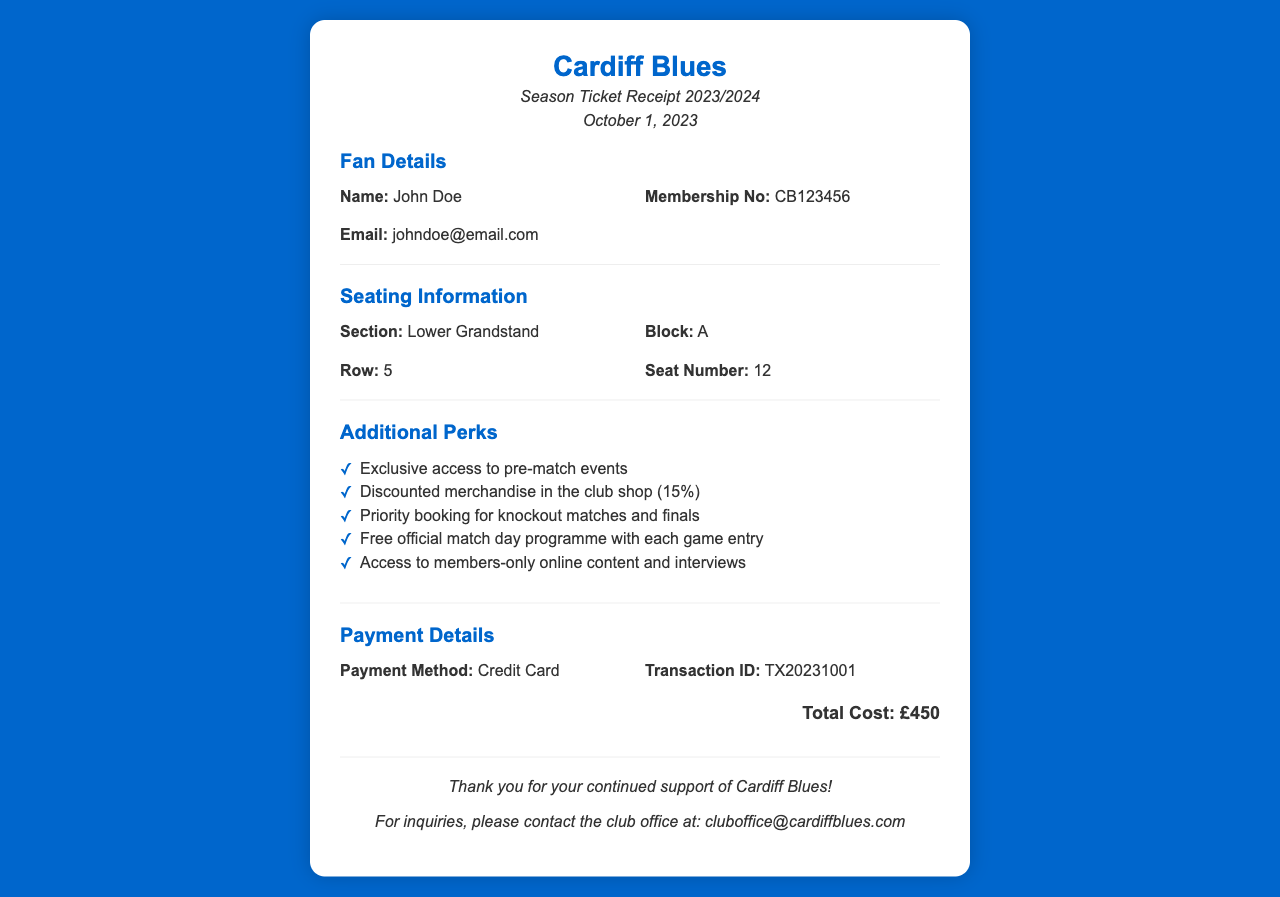what is the total cost? The total cost is mentioned in the payment details section of the document.
Answer: £450 who is the ticket holder? The name of the ticket holder is provided in the fan details section.
Answer: John Doe what is the seating section? The seating section is specified in the seating information section.
Answer: Lower Grandstand what is the membership number? The membership number is provided in the fan details section for identification.
Answer: CB123456 what percentage discount is offered on merchandise? The discount percentage for merchandise is listed in the additional perks section.
Answer: 15% what is the seat number? The seat number is included in the seating information section of the receipt.
Answer: 12 what payment method was used? The payment method is stated in the payment details section of the document.
Answer: Credit Card what kind of events do ticket holders have exclusive access to? The type of events mentioned in the additional perks section.
Answer: Pre-match events how many perks are listed? The total number of perks is counted in the additional perks section of the document.
Answer: 5 